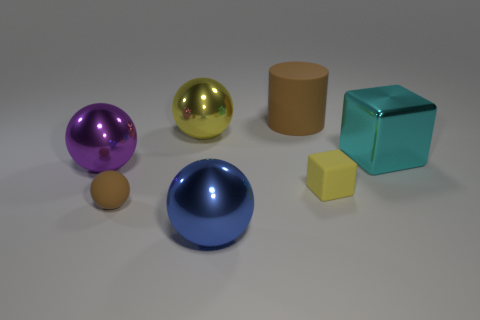What number of other objects are there of the same color as the big matte object?
Offer a terse response. 1. Do the big cyan thing and the matte thing that is right of the matte cylinder have the same shape?
Offer a terse response. Yes. There is a small matte thing that is the same shape as the yellow metallic object; what is its color?
Your answer should be very brief. Brown. Are there any big things in front of the big yellow shiny ball?
Your response must be concise. Yes. Do the blue thing and the big sphere that is on the left side of the tiny brown matte sphere have the same material?
Ensure brevity in your answer.  Yes. There is a brown matte thing that is on the left side of the big yellow metallic ball; is its shape the same as the large yellow metallic object?
Your answer should be very brief. Yes. How many cyan cubes have the same material as the purple thing?
Ensure brevity in your answer.  1. What number of objects are metallic objects on the right side of the yellow rubber cube or tiny brown cubes?
Offer a terse response. 1. How big is the purple shiny ball?
Give a very brief answer. Large. There is a brown object that is behind the tiny thing that is right of the large blue metal object; what is its material?
Give a very brief answer. Rubber. 